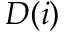<formula> <loc_0><loc_0><loc_500><loc_500>D ( i )</formula> 